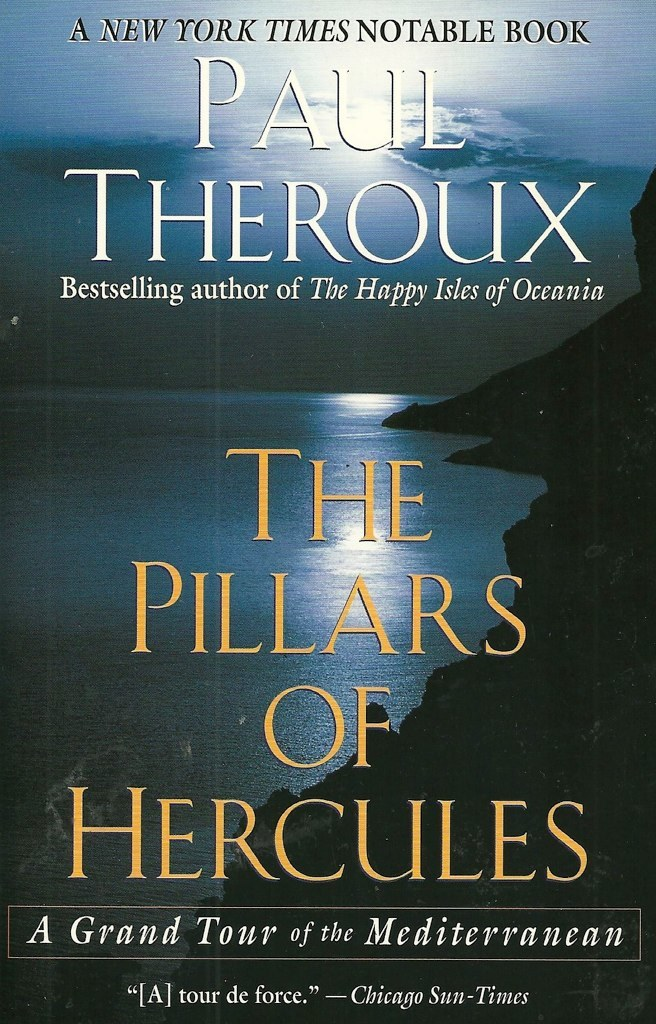How does the cover image reflect the theme of the book? The cover image of a cliff overlooking the sea encapsulates the book's themes of travel and the vastness of human experience in the Mediterranean. The tranquil yet imposing landscape invites readers into a world of expansive horizons and unknown possibilities, embodying the physical and metaphorical journeys Paul Theroux describes in his narrative. The deep blues and the distant shoreline evoke a sense of both adventure and contemplation, key elements in Theroux's travel writing. 